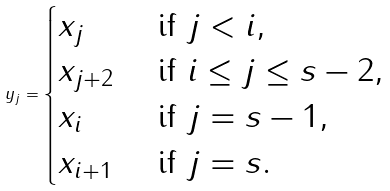Convert formula to latex. <formula><loc_0><loc_0><loc_500><loc_500>y _ { j } = \begin{cases} x _ { j } & \text { if } j < i , \\ x _ { j + 2 } & \text { if } i \leq j \leq s - 2 , \\ x _ { i } & \text { if } j = s - 1 , \\ x _ { i + 1 } & \text { if } j = s . \end{cases}</formula> 